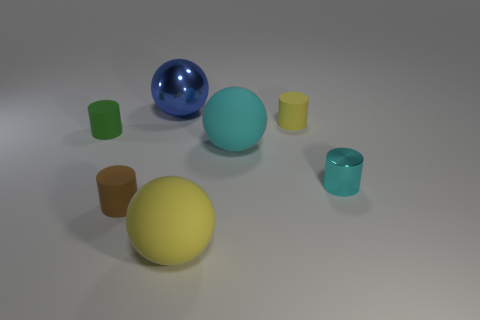Do the cyan metal cylinder and the green cylinder have the same size?
Offer a very short reply. Yes. What number of cylinders are either big yellow things or large cyan rubber objects?
Offer a very short reply. 0. What material is the large object that is the same color as the metallic cylinder?
Your answer should be very brief. Rubber. How many big metal things have the same shape as the green matte object?
Your response must be concise. 0. Are there more big blue objects behind the tiny brown rubber thing than cyan matte objects behind the small yellow object?
Provide a short and direct response. Yes. Is the color of the large matte object behind the brown thing the same as the shiny cylinder?
Offer a very short reply. Yes. The yellow sphere has what size?
Give a very brief answer. Large. There is a blue ball that is the same size as the yellow matte sphere; what is it made of?
Provide a short and direct response. Metal. What is the color of the object in front of the tiny brown rubber cylinder?
Your answer should be compact. Yellow. How many tiny green matte objects are there?
Keep it short and to the point. 1. 